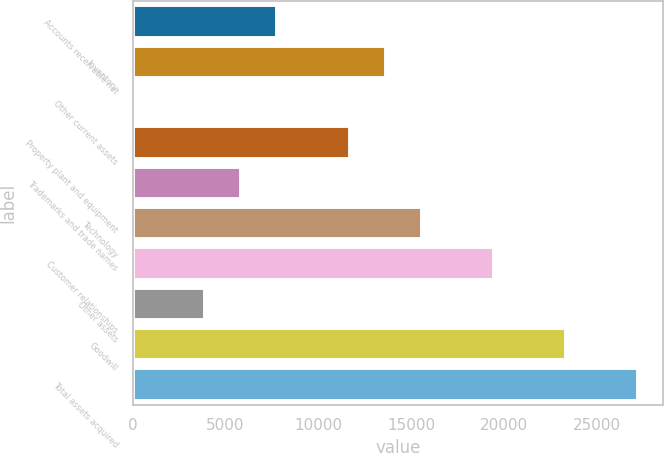Convert chart to OTSL. <chart><loc_0><loc_0><loc_500><loc_500><bar_chart><fcel>Accounts receivable net<fcel>Inventory<fcel>Other current assets<fcel>Property plant and equipment<fcel>Trademarks and trade names<fcel>Technology<fcel>Customer relationships<fcel>Other assets<fcel>Goodwill<fcel>Total assets acquired<nl><fcel>7801.6<fcel>13633<fcel>26.4<fcel>11689.2<fcel>5857.8<fcel>15576.8<fcel>19464.4<fcel>3914<fcel>23352<fcel>27239.6<nl></chart> 